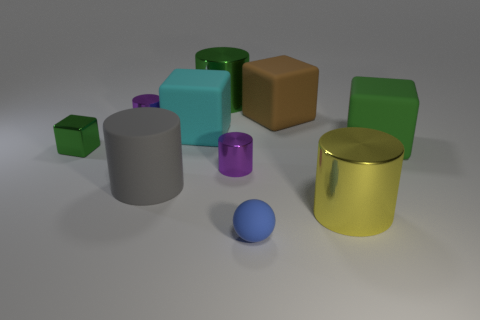Subtract all big yellow metallic cylinders. How many cylinders are left? 4 Subtract all purple cylinders. How many cylinders are left? 3 Subtract all balls. How many objects are left? 9 Subtract all cyan spheres. How many green cubes are left? 2 Subtract 0 yellow spheres. How many objects are left? 10 Subtract 3 cylinders. How many cylinders are left? 2 Subtract all cyan blocks. Subtract all gray balls. How many blocks are left? 3 Subtract all shiny objects. Subtract all large shiny objects. How many objects are left? 3 Add 7 yellow cylinders. How many yellow cylinders are left? 8 Add 7 big yellow rubber objects. How many big yellow rubber objects exist? 7 